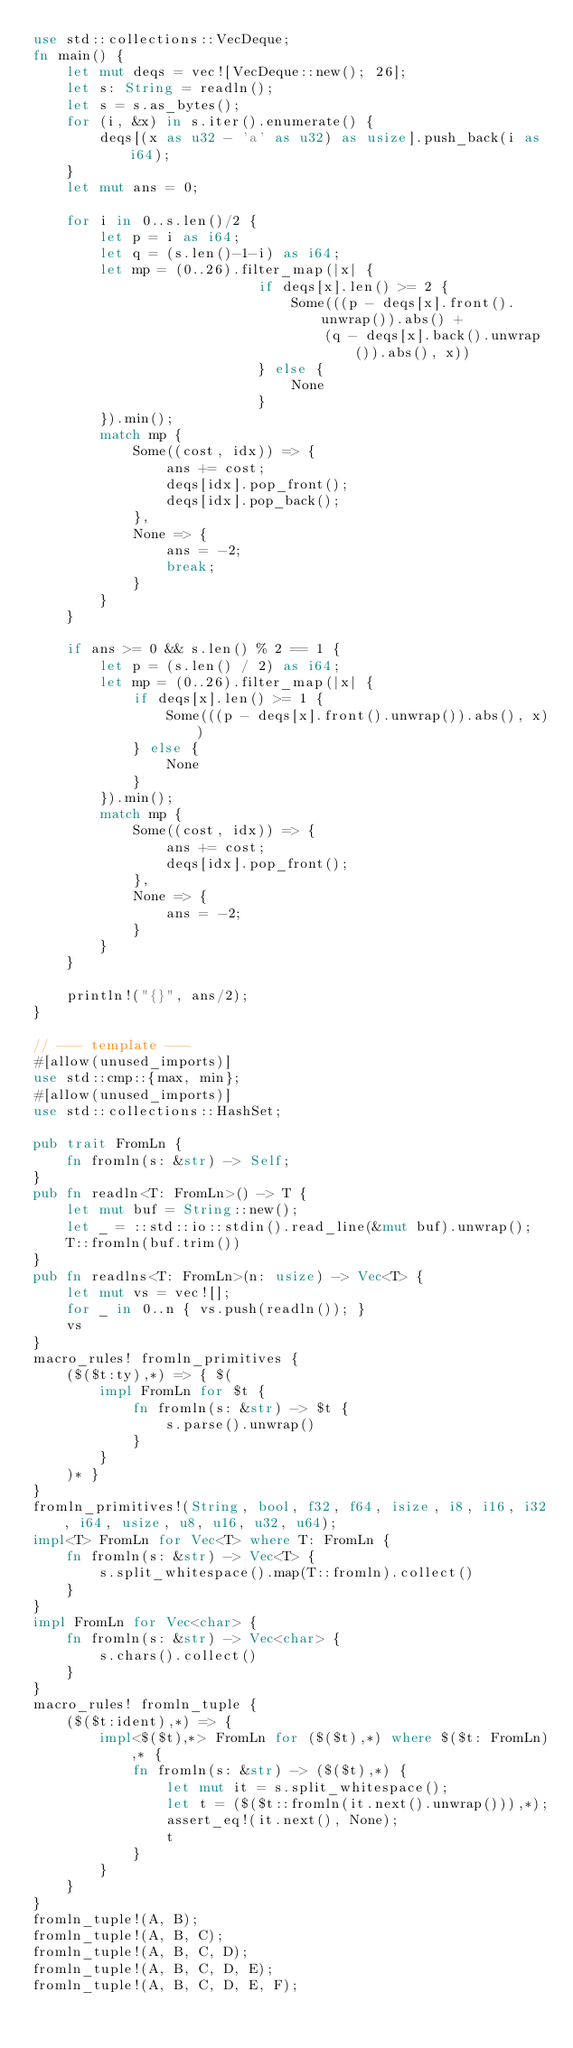<code> <loc_0><loc_0><loc_500><loc_500><_Rust_>use std::collections::VecDeque;
fn main() {
    let mut deqs = vec![VecDeque::new(); 26];
    let s: String = readln();
    let s = s.as_bytes();
    for (i, &x) in s.iter().enumerate() {
        deqs[(x as u32 - 'a' as u32) as usize].push_back(i as i64);
    }
    let mut ans = 0;

    for i in 0..s.len()/2 {
        let p = i as i64;
        let q = (s.len()-1-i) as i64;
        let mp = (0..26).filter_map(|x| {
                           if deqs[x].len() >= 2 {
                               Some(((p - deqs[x].front().unwrap()).abs() + 
                                   (q - deqs[x].back().unwrap()).abs(), x))
                           } else {
                               None
                           }
        }).min();
        match mp {
            Some((cost, idx)) => {
                ans += cost;
                deqs[idx].pop_front();
                deqs[idx].pop_back();
            },
            None => {
                ans = -2;
                break;
            }
        }
    }

    if ans >= 0 && s.len() % 2 == 1 {
        let p = (s.len() / 2) as i64;
        let mp = (0..26).filter_map(|x| {
            if deqs[x].len() >= 1 {
                Some(((p - deqs[x].front().unwrap()).abs(), x))
            } else {
                None
            }
        }).min();
        match mp {
            Some((cost, idx)) => {
                ans += cost;
                deqs[idx].pop_front();
            },
            None => {
                ans = -2;
            }
        }
    }

    println!("{}", ans/2);
}

// --- template ---
#[allow(unused_imports)]
use std::cmp::{max, min};
#[allow(unused_imports)]
use std::collections::HashSet;

pub trait FromLn {
    fn fromln(s: &str) -> Self;
}
pub fn readln<T: FromLn>() -> T {
    let mut buf = String::new();
    let _ = ::std::io::stdin().read_line(&mut buf).unwrap();
    T::fromln(buf.trim())
}
pub fn readlns<T: FromLn>(n: usize) -> Vec<T> {
    let mut vs = vec![];
    for _ in 0..n { vs.push(readln()); }
    vs
}
macro_rules! fromln_primitives {
    ($($t:ty),*) => { $(
        impl FromLn for $t {
            fn fromln(s: &str) -> $t {
                s.parse().unwrap()
            }
        }
    )* }
}
fromln_primitives!(String, bool, f32, f64, isize, i8, i16, i32, i64, usize, u8, u16, u32, u64);
impl<T> FromLn for Vec<T> where T: FromLn {
    fn fromln(s: &str) -> Vec<T> {
        s.split_whitespace().map(T::fromln).collect()
    }
}
impl FromLn for Vec<char> {
    fn fromln(s: &str) -> Vec<char> {
        s.chars().collect()
    }
}
macro_rules! fromln_tuple {
    ($($t:ident),*) => {
        impl<$($t),*> FromLn for ($($t),*) where $($t: FromLn),* {
            fn fromln(s: &str) -> ($($t),*) {
                let mut it = s.split_whitespace();
                let t = ($($t::fromln(it.next().unwrap())),*);
                assert_eq!(it.next(), None);
                t
            }
        }
    }
}
fromln_tuple!(A, B);
fromln_tuple!(A, B, C);
fromln_tuple!(A, B, C, D);
fromln_tuple!(A, B, C, D, E);
fromln_tuple!(A, B, C, D, E, F);
</code> 